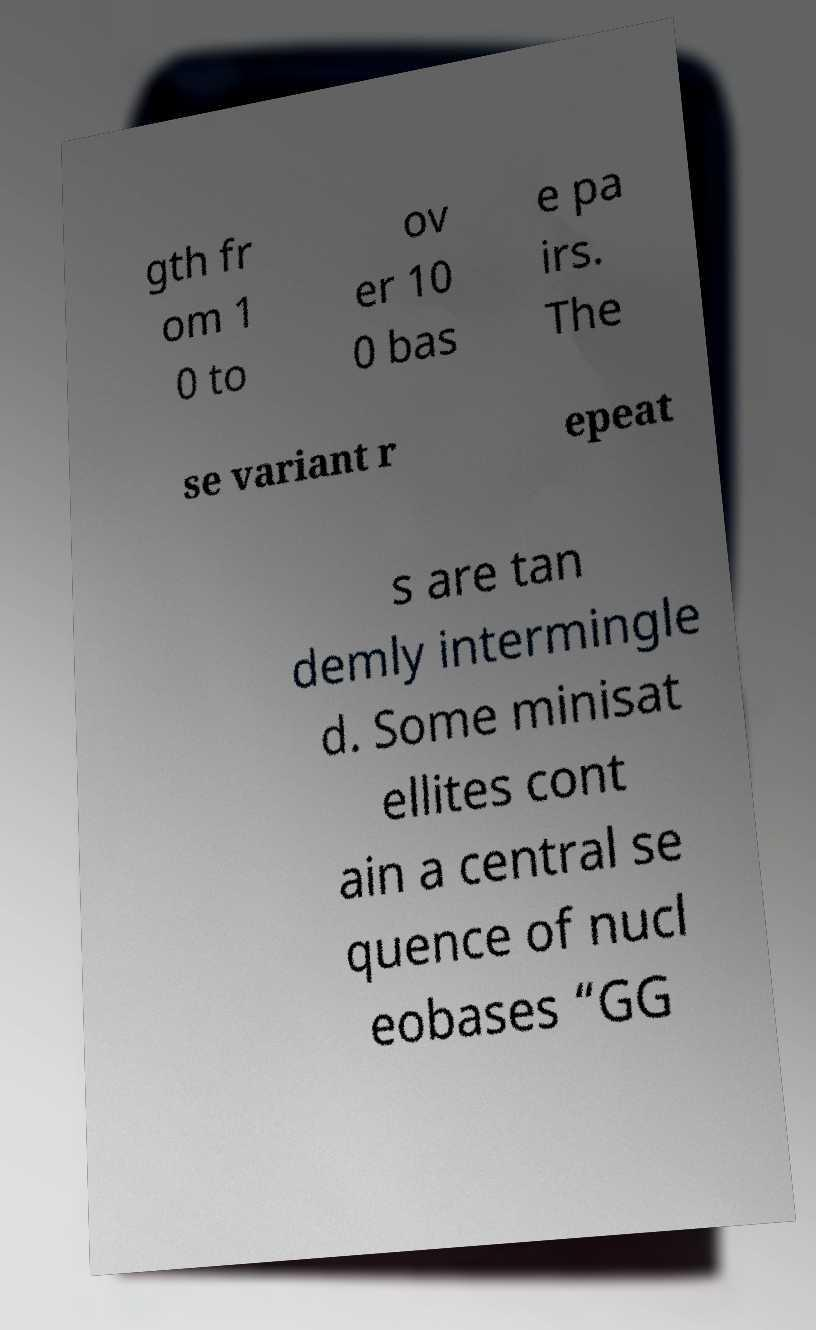For documentation purposes, I need the text within this image transcribed. Could you provide that? gth fr om 1 0 to ov er 10 0 bas e pa irs. The se variant r epeat s are tan demly intermingle d. Some minisat ellites cont ain a central se quence of nucl eobases “GG 